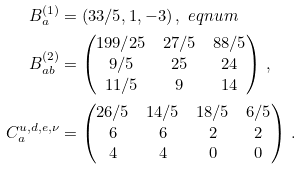Convert formula to latex. <formula><loc_0><loc_0><loc_500><loc_500>B _ { a } ^ { ( 1 ) } & = ( 3 3 / 5 , 1 , - 3 ) \, , \ e q n u m \\ B ^ { ( 2 ) } _ { a b } & = \begin{pmatrix} { 1 9 9 / 2 5 } & { 2 7 / 5 } & { 8 8 / 5 } \\ { 9 / 5 } & 2 5 & 2 4 \\ { 1 1 / 5 } & 9 & 1 4 \end{pmatrix} \, , \\ C ^ { u , d , e , \nu } _ { a } & = \begin{pmatrix} { 2 6 / 5 } & { 1 4 / 5 } & { 1 8 / 5 } & 6 / 5 \\ 6 & 6 & 2 & 2 \\ 4 & 4 & 0 & 0 \end{pmatrix} \, .</formula> 